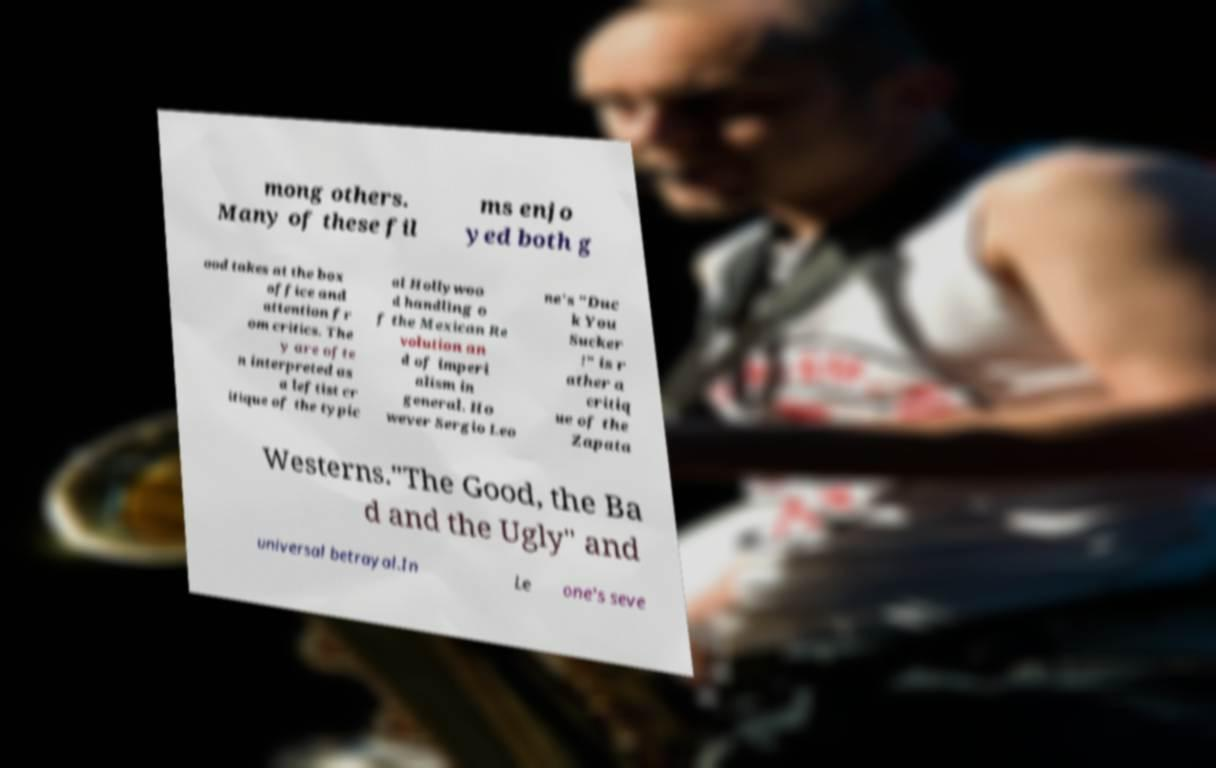What messages or text are displayed in this image? I need them in a readable, typed format. mong others. Many of these fil ms enjo yed both g ood takes at the box office and attention fr om critics. The y are ofte n interpreted as a leftist cr itique of the typic al Hollywoo d handling o f the Mexican Re volution an d of imperi alism in general. Ho wever Sergio Leo ne's "Duc k You Sucker !" is r ather a critiq ue of the Zapata Westerns."The Good, the Ba d and the Ugly" and universal betrayal.In Le one's seve 